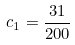Convert formula to latex. <formula><loc_0><loc_0><loc_500><loc_500>c _ { 1 } = \frac { 3 1 } { 2 0 0 }</formula> 